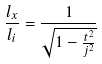Convert formula to latex. <formula><loc_0><loc_0><loc_500><loc_500>\frac { l _ { x } } { l _ { i } } = \frac { 1 } { \sqrt { 1 - \frac { t ^ { 2 } } { j ^ { 2 } } } }</formula> 